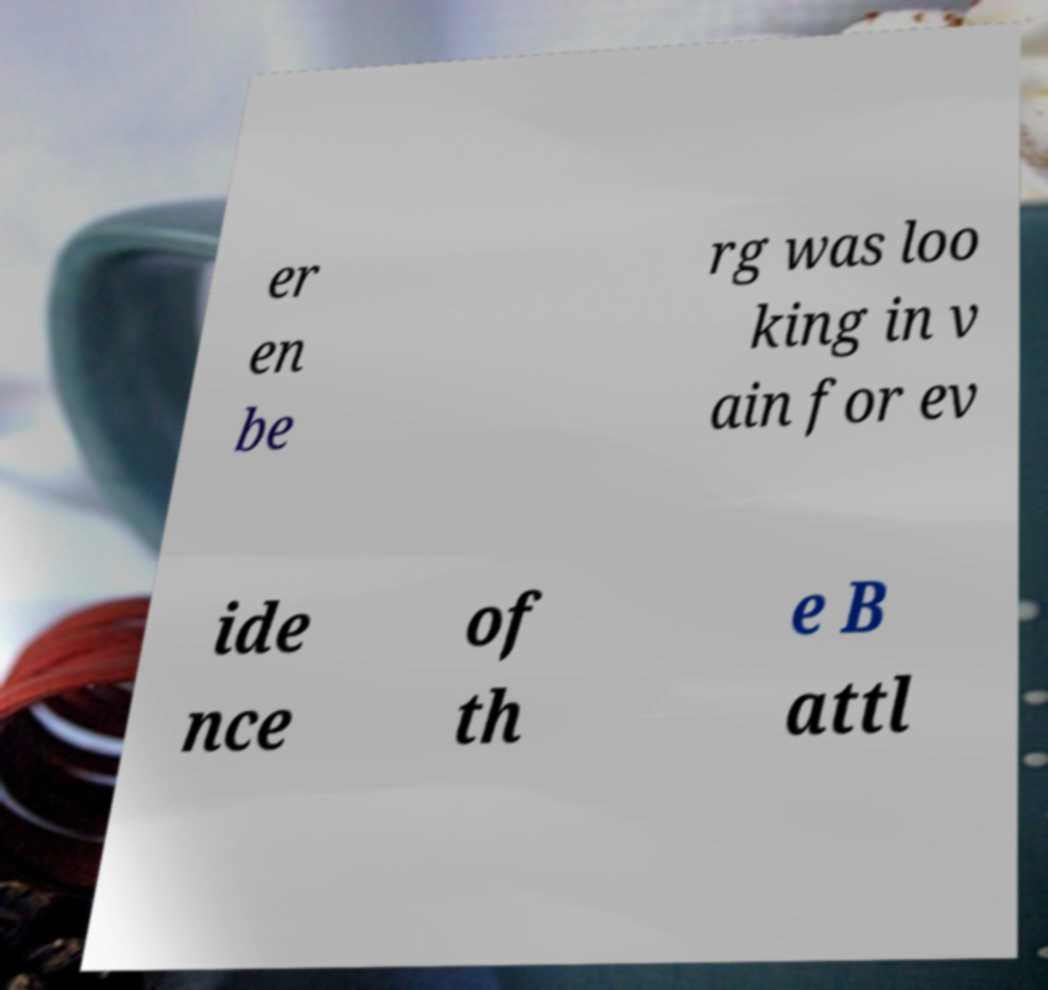Please identify and transcribe the text found in this image. er en be rg was loo king in v ain for ev ide nce of th e B attl 